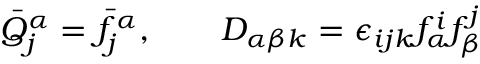Convert formula to latex. <formula><loc_0><loc_0><loc_500><loc_500>\bar { Q } _ { j } ^ { \alpha } = \bar { f } _ { j } ^ { \alpha } , D _ { \alpha \beta k } = \epsilon _ { i j k } f _ { \alpha } ^ { i } f _ { \beta } ^ { j }</formula> 